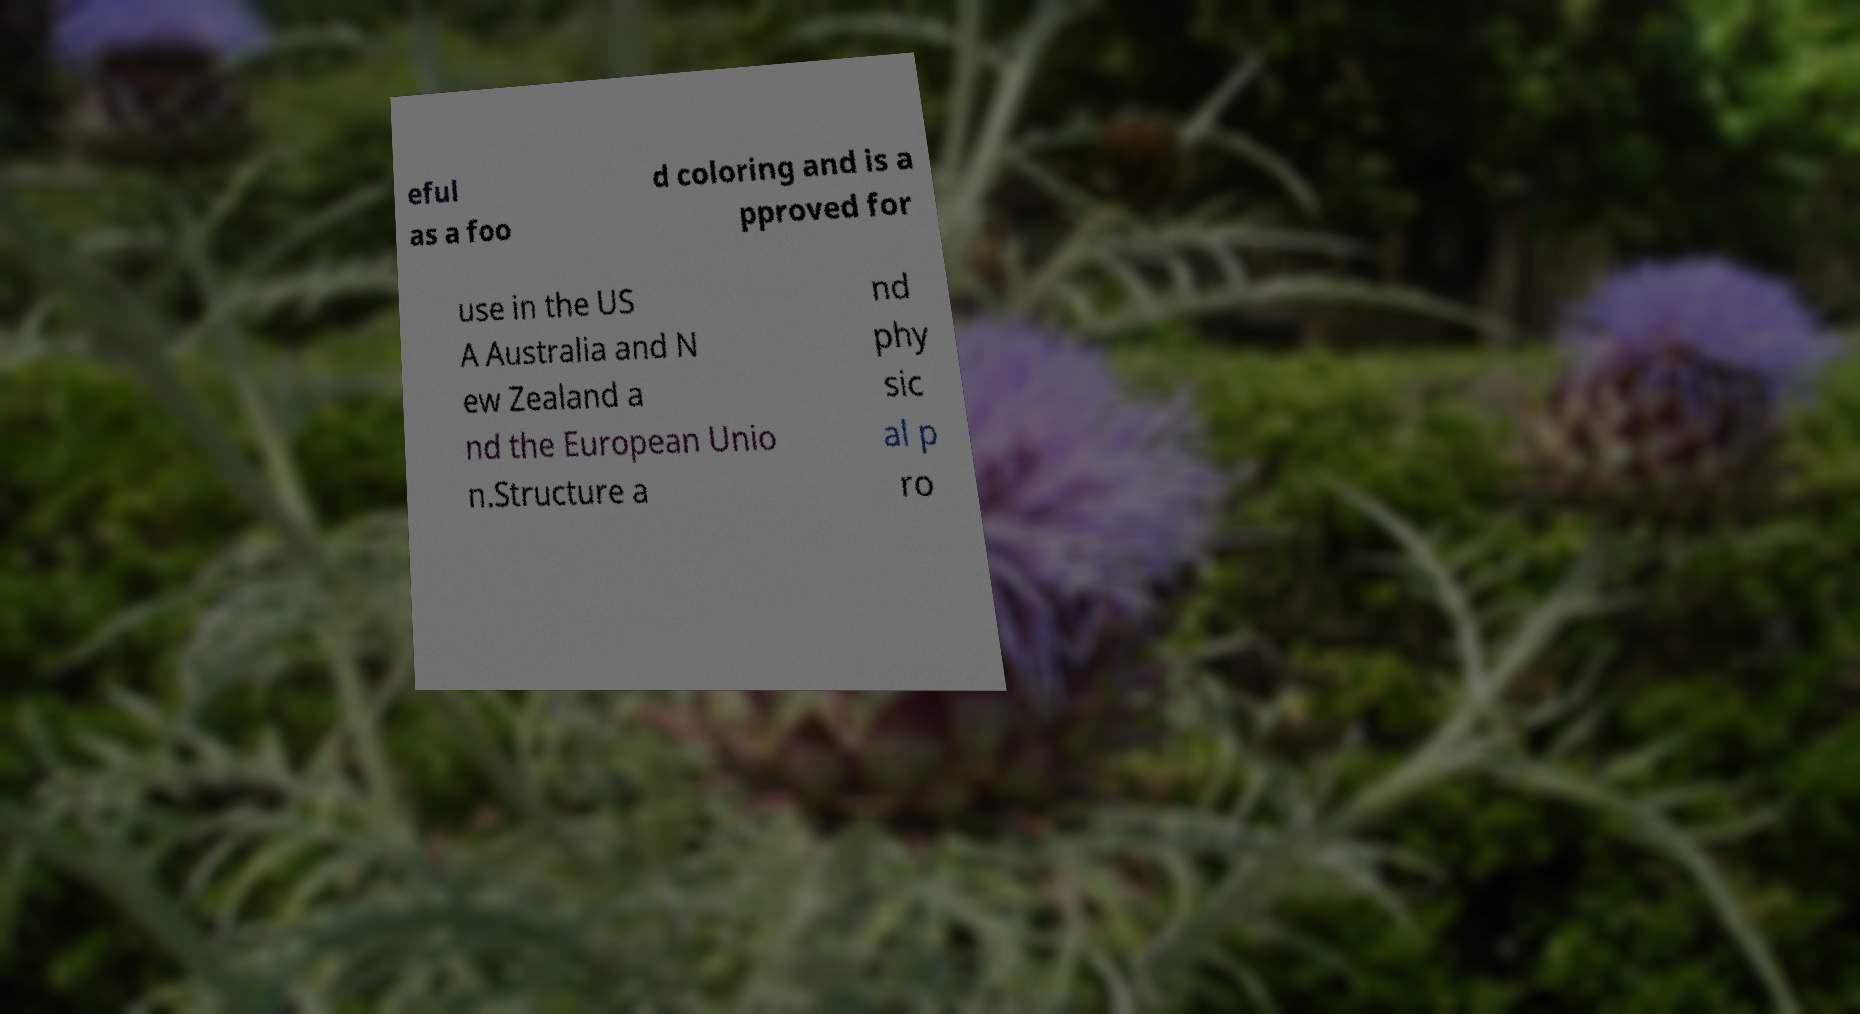There's text embedded in this image that I need extracted. Can you transcribe it verbatim? eful as a foo d coloring and is a pproved for use in the US A Australia and N ew Zealand a nd the European Unio n.Structure a nd phy sic al p ro 